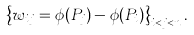Convert formula to latex. <formula><loc_0><loc_0><loc_500><loc_500>\left \{ w _ { i j } = \phi ( P _ { j } ) - \phi ( P _ { i } ) \right \} _ { i < j < n } .</formula> 